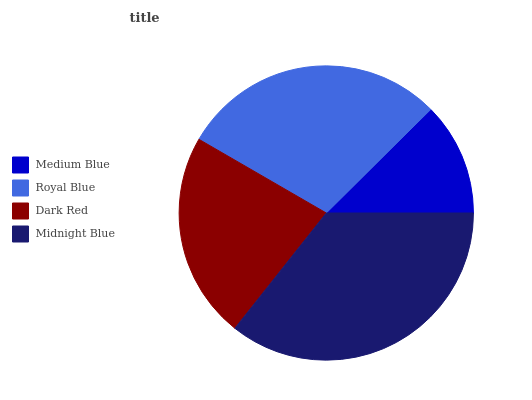Is Medium Blue the minimum?
Answer yes or no. Yes. Is Midnight Blue the maximum?
Answer yes or no. Yes. Is Royal Blue the minimum?
Answer yes or no. No. Is Royal Blue the maximum?
Answer yes or no. No. Is Royal Blue greater than Medium Blue?
Answer yes or no. Yes. Is Medium Blue less than Royal Blue?
Answer yes or no. Yes. Is Medium Blue greater than Royal Blue?
Answer yes or no. No. Is Royal Blue less than Medium Blue?
Answer yes or no. No. Is Royal Blue the high median?
Answer yes or no. Yes. Is Dark Red the low median?
Answer yes or no. Yes. Is Midnight Blue the high median?
Answer yes or no. No. Is Medium Blue the low median?
Answer yes or no. No. 